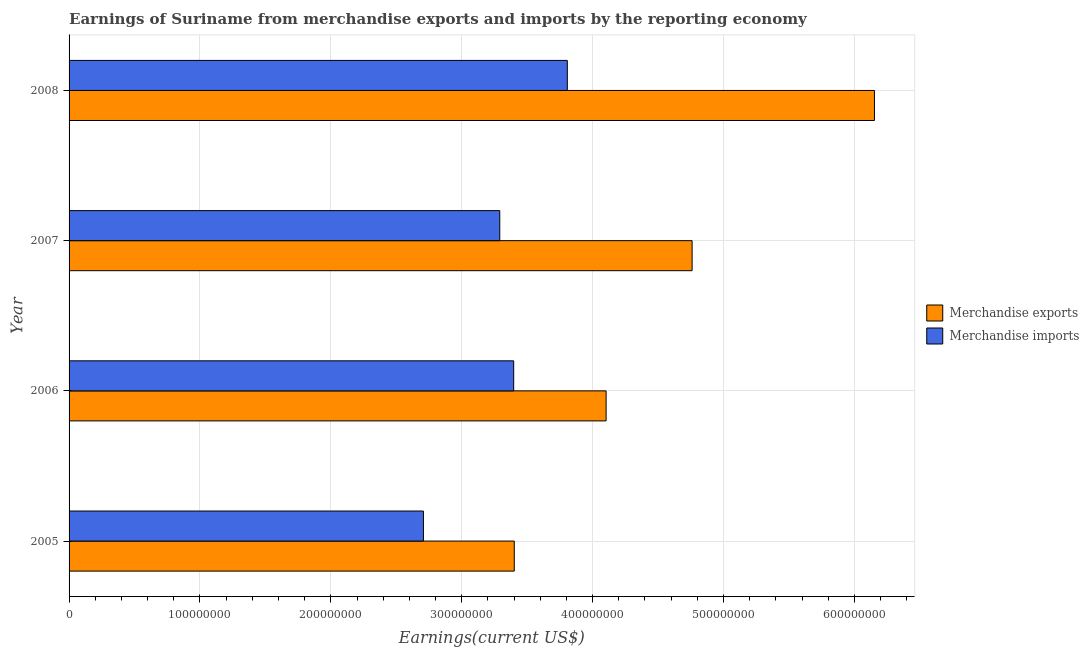How many bars are there on the 1st tick from the bottom?
Provide a short and direct response. 2. What is the earnings from merchandise imports in 2006?
Your response must be concise. 3.40e+08. Across all years, what is the maximum earnings from merchandise exports?
Your response must be concise. 6.15e+08. Across all years, what is the minimum earnings from merchandise imports?
Your answer should be compact. 2.71e+08. In which year was the earnings from merchandise exports maximum?
Give a very brief answer. 2008. In which year was the earnings from merchandise exports minimum?
Your answer should be very brief. 2005. What is the total earnings from merchandise exports in the graph?
Your response must be concise. 1.84e+09. What is the difference between the earnings from merchandise imports in 2006 and that in 2008?
Keep it short and to the point. -4.10e+07. What is the difference between the earnings from merchandise exports in 2008 and the earnings from merchandise imports in 2007?
Provide a succinct answer. 2.86e+08. What is the average earnings from merchandise imports per year?
Offer a terse response. 3.30e+08. In the year 2007, what is the difference between the earnings from merchandise imports and earnings from merchandise exports?
Offer a terse response. -1.47e+08. What is the ratio of the earnings from merchandise exports in 2006 to that in 2007?
Ensure brevity in your answer.  0.86. Is the earnings from merchandise exports in 2006 less than that in 2008?
Your answer should be compact. Yes. Is the difference between the earnings from merchandise imports in 2005 and 2008 greater than the difference between the earnings from merchandise exports in 2005 and 2008?
Keep it short and to the point. Yes. What is the difference between the highest and the second highest earnings from merchandise exports?
Ensure brevity in your answer.  1.39e+08. What is the difference between the highest and the lowest earnings from merchandise exports?
Provide a short and direct response. 2.75e+08. In how many years, is the earnings from merchandise exports greater than the average earnings from merchandise exports taken over all years?
Your answer should be very brief. 2. Are all the bars in the graph horizontal?
Your answer should be compact. Yes. What is the difference between two consecutive major ticks on the X-axis?
Offer a very short reply. 1.00e+08. How many legend labels are there?
Your answer should be compact. 2. How are the legend labels stacked?
Provide a succinct answer. Vertical. What is the title of the graph?
Make the answer very short. Earnings of Suriname from merchandise exports and imports by the reporting economy. Does "Export" appear as one of the legend labels in the graph?
Your answer should be very brief. No. What is the label or title of the X-axis?
Provide a short and direct response. Earnings(current US$). What is the Earnings(current US$) of Merchandise exports in 2005?
Give a very brief answer. 3.40e+08. What is the Earnings(current US$) of Merchandise imports in 2005?
Offer a terse response. 2.71e+08. What is the Earnings(current US$) of Merchandise exports in 2006?
Your response must be concise. 4.10e+08. What is the Earnings(current US$) of Merchandise imports in 2006?
Give a very brief answer. 3.40e+08. What is the Earnings(current US$) of Merchandise exports in 2007?
Provide a succinct answer. 4.76e+08. What is the Earnings(current US$) in Merchandise imports in 2007?
Your answer should be compact. 3.29e+08. What is the Earnings(current US$) in Merchandise exports in 2008?
Offer a very short reply. 6.15e+08. What is the Earnings(current US$) in Merchandise imports in 2008?
Provide a succinct answer. 3.81e+08. Across all years, what is the maximum Earnings(current US$) in Merchandise exports?
Offer a very short reply. 6.15e+08. Across all years, what is the maximum Earnings(current US$) of Merchandise imports?
Offer a terse response. 3.81e+08. Across all years, what is the minimum Earnings(current US$) in Merchandise exports?
Ensure brevity in your answer.  3.40e+08. Across all years, what is the minimum Earnings(current US$) of Merchandise imports?
Provide a succinct answer. 2.71e+08. What is the total Earnings(current US$) of Merchandise exports in the graph?
Provide a short and direct response. 1.84e+09. What is the total Earnings(current US$) of Merchandise imports in the graph?
Make the answer very short. 1.32e+09. What is the difference between the Earnings(current US$) in Merchandise exports in 2005 and that in 2006?
Your answer should be compact. -7.02e+07. What is the difference between the Earnings(current US$) in Merchandise imports in 2005 and that in 2006?
Your answer should be compact. -6.90e+07. What is the difference between the Earnings(current US$) of Merchandise exports in 2005 and that in 2007?
Provide a succinct answer. -1.36e+08. What is the difference between the Earnings(current US$) in Merchandise imports in 2005 and that in 2007?
Provide a short and direct response. -5.83e+07. What is the difference between the Earnings(current US$) of Merchandise exports in 2005 and that in 2008?
Make the answer very short. -2.75e+08. What is the difference between the Earnings(current US$) of Merchandise imports in 2005 and that in 2008?
Ensure brevity in your answer.  -1.10e+08. What is the difference between the Earnings(current US$) of Merchandise exports in 2006 and that in 2007?
Your response must be concise. -6.57e+07. What is the difference between the Earnings(current US$) of Merchandise imports in 2006 and that in 2007?
Offer a very short reply. 1.06e+07. What is the difference between the Earnings(current US$) in Merchandise exports in 2006 and that in 2008?
Your answer should be compact. -2.05e+08. What is the difference between the Earnings(current US$) in Merchandise imports in 2006 and that in 2008?
Offer a terse response. -4.10e+07. What is the difference between the Earnings(current US$) in Merchandise exports in 2007 and that in 2008?
Your response must be concise. -1.39e+08. What is the difference between the Earnings(current US$) of Merchandise imports in 2007 and that in 2008?
Offer a very short reply. -5.16e+07. What is the difference between the Earnings(current US$) in Merchandise exports in 2005 and the Earnings(current US$) in Merchandise imports in 2006?
Provide a short and direct response. 4.38e+05. What is the difference between the Earnings(current US$) in Merchandise exports in 2005 and the Earnings(current US$) in Merchandise imports in 2007?
Make the answer very short. 1.11e+07. What is the difference between the Earnings(current US$) in Merchandise exports in 2005 and the Earnings(current US$) in Merchandise imports in 2008?
Keep it short and to the point. -4.05e+07. What is the difference between the Earnings(current US$) of Merchandise exports in 2006 and the Earnings(current US$) of Merchandise imports in 2007?
Ensure brevity in your answer.  8.12e+07. What is the difference between the Earnings(current US$) of Merchandise exports in 2006 and the Earnings(current US$) of Merchandise imports in 2008?
Ensure brevity in your answer.  2.96e+07. What is the difference between the Earnings(current US$) in Merchandise exports in 2007 and the Earnings(current US$) in Merchandise imports in 2008?
Give a very brief answer. 9.53e+07. What is the average Earnings(current US$) of Merchandise exports per year?
Offer a very short reply. 4.60e+08. What is the average Earnings(current US$) of Merchandise imports per year?
Offer a very short reply. 3.30e+08. In the year 2005, what is the difference between the Earnings(current US$) in Merchandise exports and Earnings(current US$) in Merchandise imports?
Keep it short and to the point. 6.94e+07. In the year 2006, what is the difference between the Earnings(current US$) of Merchandise exports and Earnings(current US$) of Merchandise imports?
Offer a very short reply. 7.06e+07. In the year 2007, what is the difference between the Earnings(current US$) in Merchandise exports and Earnings(current US$) in Merchandise imports?
Your response must be concise. 1.47e+08. In the year 2008, what is the difference between the Earnings(current US$) in Merchandise exports and Earnings(current US$) in Merchandise imports?
Offer a very short reply. 2.35e+08. What is the ratio of the Earnings(current US$) of Merchandise exports in 2005 to that in 2006?
Provide a short and direct response. 0.83. What is the ratio of the Earnings(current US$) of Merchandise imports in 2005 to that in 2006?
Your response must be concise. 0.8. What is the ratio of the Earnings(current US$) in Merchandise exports in 2005 to that in 2007?
Provide a succinct answer. 0.71. What is the ratio of the Earnings(current US$) of Merchandise imports in 2005 to that in 2007?
Make the answer very short. 0.82. What is the ratio of the Earnings(current US$) in Merchandise exports in 2005 to that in 2008?
Your answer should be very brief. 0.55. What is the ratio of the Earnings(current US$) in Merchandise imports in 2005 to that in 2008?
Your answer should be very brief. 0.71. What is the ratio of the Earnings(current US$) of Merchandise exports in 2006 to that in 2007?
Provide a short and direct response. 0.86. What is the ratio of the Earnings(current US$) in Merchandise imports in 2006 to that in 2007?
Give a very brief answer. 1.03. What is the ratio of the Earnings(current US$) of Merchandise exports in 2006 to that in 2008?
Make the answer very short. 0.67. What is the ratio of the Earnings(current US$) of Merchandise imports in 2006 to that in 2008?
Make the answer very short. 0.89. What is the ratio of the Earnings(current US$) of Merchandise exports in 2007 to that in 2008?
Make the answer very short. 0.77. What is the ratio of the Earnings(current US$) of Merchandise imports in 2007 to that in 2008?
Give a very brief answer. 0.86. What is the difference between the highest and the second highest Earnings(current US$) of Merchandise exports?
Make the answer very short. 1.39e+08. What is the difference between the highest and the second highest Earnings(current US$) of Merchandise imports?
Make the answer very short. 4.10e+07. What is the difference between the highest and the lowest Earnings(current US$) in Merchandise exports?
Your response must be concise. 2.75e+08. What is the difference between the highest and the lowest Earnings(current US$) in Merchandise imports?
Your answer should be compact. 1.10e+08. 